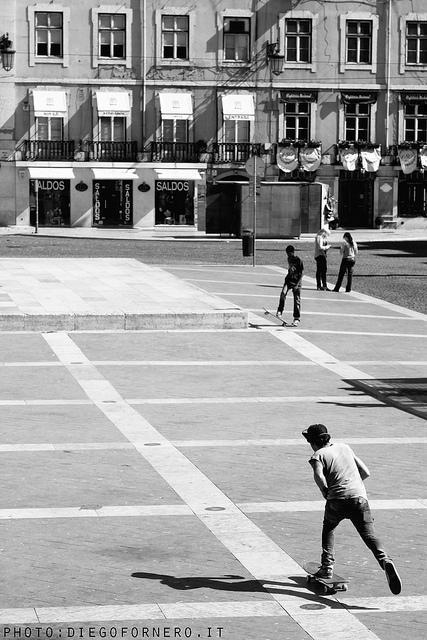Why is the boy kicking his leg back?
Indicate the correct response by choosing from the four available options to answer the question.
Options: For speed, to fight, to flip, to roll. For speed. 